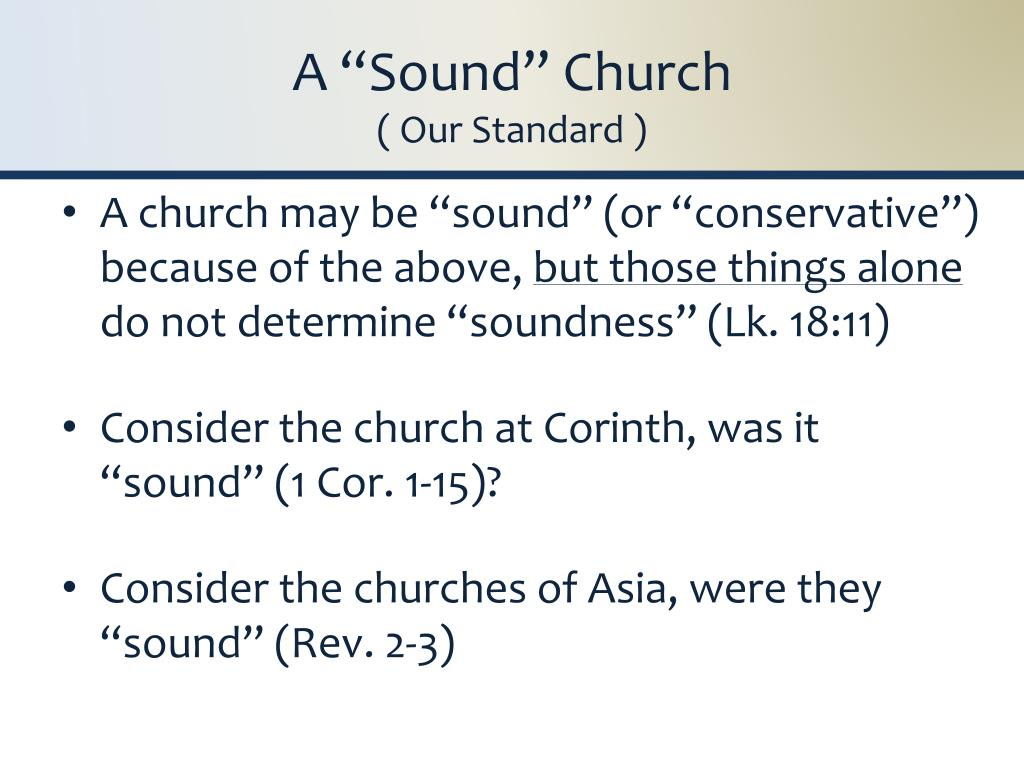How can a church apply the lessons from Luke 18:11 in its daily operations and teachings? To apply the lessons from Luke 18:11, a church can emphasize humility and service in its teachings. This scripture criticizes the self-righteous attitude displayed by the Pharisee who prays proudly about himself. Churches can foster a community that values modesty, encourages confession and repentance of sins, and focuses on helping others rather than judging them. Workshops, sermons, and community outreach programs could be oriented around these values to practically implement this lesson. 